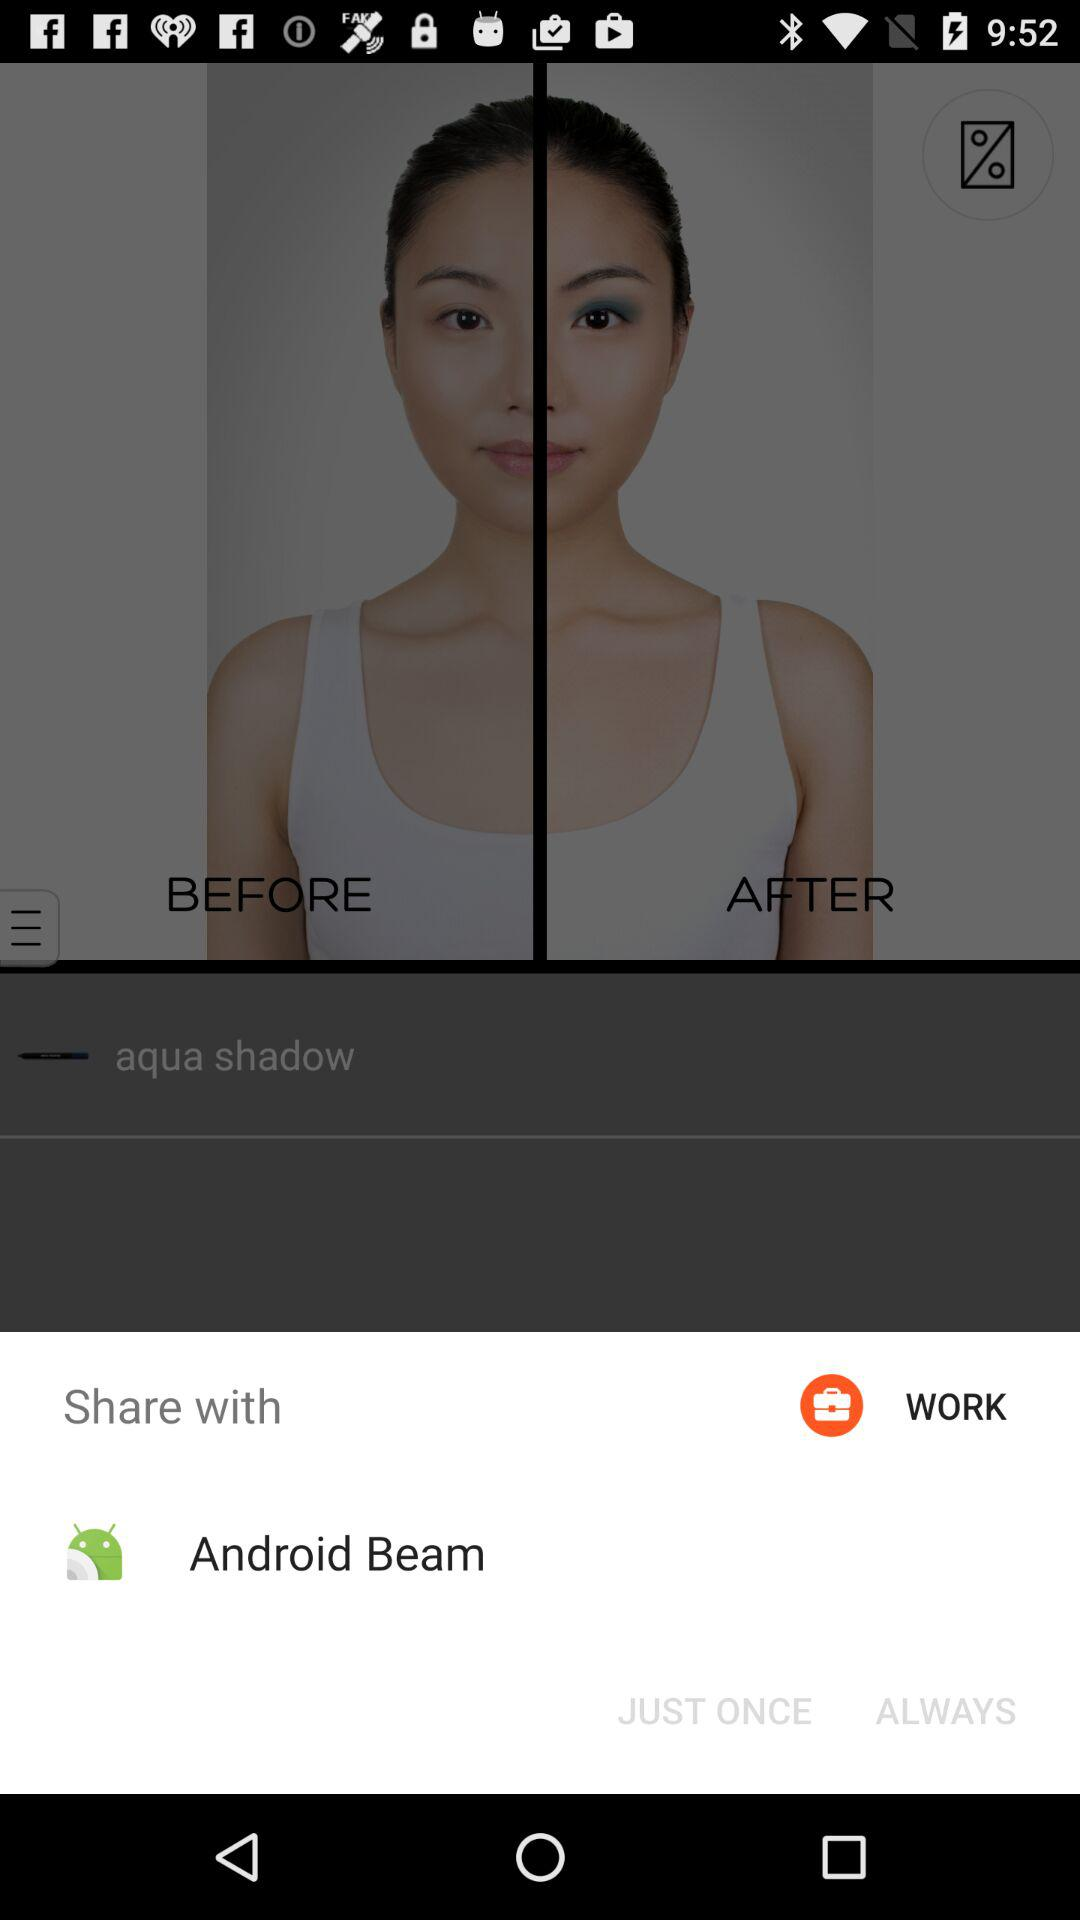What application can I use to share? You can use "Android Beam" to share. 